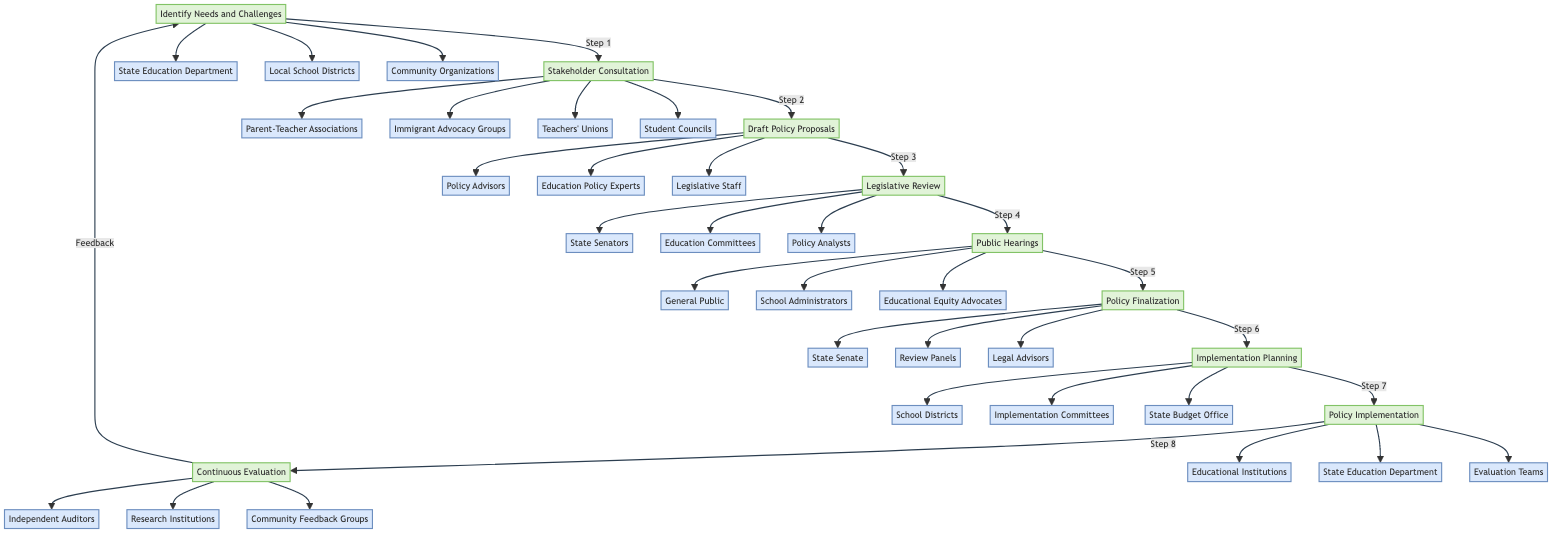What is the first step in the policy development process? The first step in the diagram is "Identify Needs and Challenges," which initiates the process of developing equitable education policies.
Answer: Identify Needs and Challenges How many steps are there in total? The diagram outlines nine distinct steps in the policy development process, ranging from identifying needs to continuous evaluation.
Answer: Nine Which entities are involved in the "Stakeholder Consultation" step? The step "Stakeholder Consultation" lists the following entities involved: Parent-Teacher Associations, Immigrant Advocacy Groups, Teachers' Unions, and Student Councils.
Answer: Parent-Teacher Associations, Immigrant Advocacy Groups, Teachers' Unions, Student Councils What step comes after "Public Hearings"? The diagram shows that "Policy Finalization" follows "Public Hearings," indicating that after collecting public opinions, the policy proposal is finalized.
Answer: Policy Finalization Name the last step in the process. The last step depicted in the flowchart is "Continuous Evaluation," which emphasizes the importance of ongoing assessment in the policy process.
Answer: Continuous Evaluation Which entities contribute to the "Implementation Planning" step? The entities involved in "Implementation Planning" as per the flowchart are School Districts, Implementation Committees, and State Budget Office, highlighting collaborative planning.
Answer: School Districts, Implementation Committees, State Budget Office How many entities are connected to the "Legislative Review" step? The "Legislative Review" step has three entities connected to it: State Senators, Education Committees, and Policy Analysts, indicating a collaborative review process.
Answer: Three Which step precedes "Draft Policy Proposals"? The step preceding "Draft Policy Proposals" is "Stakeholder Consultation," where insights and recommendations are gathered before drafting any proposals.
Answer: Stakeholder Consultation What kind of processes can be observed in this flowchart? The diagram represents a linear sequential process, as each step leads to the next, demonstrating an organized flow of policy development.
Answer: Linear sequential process 